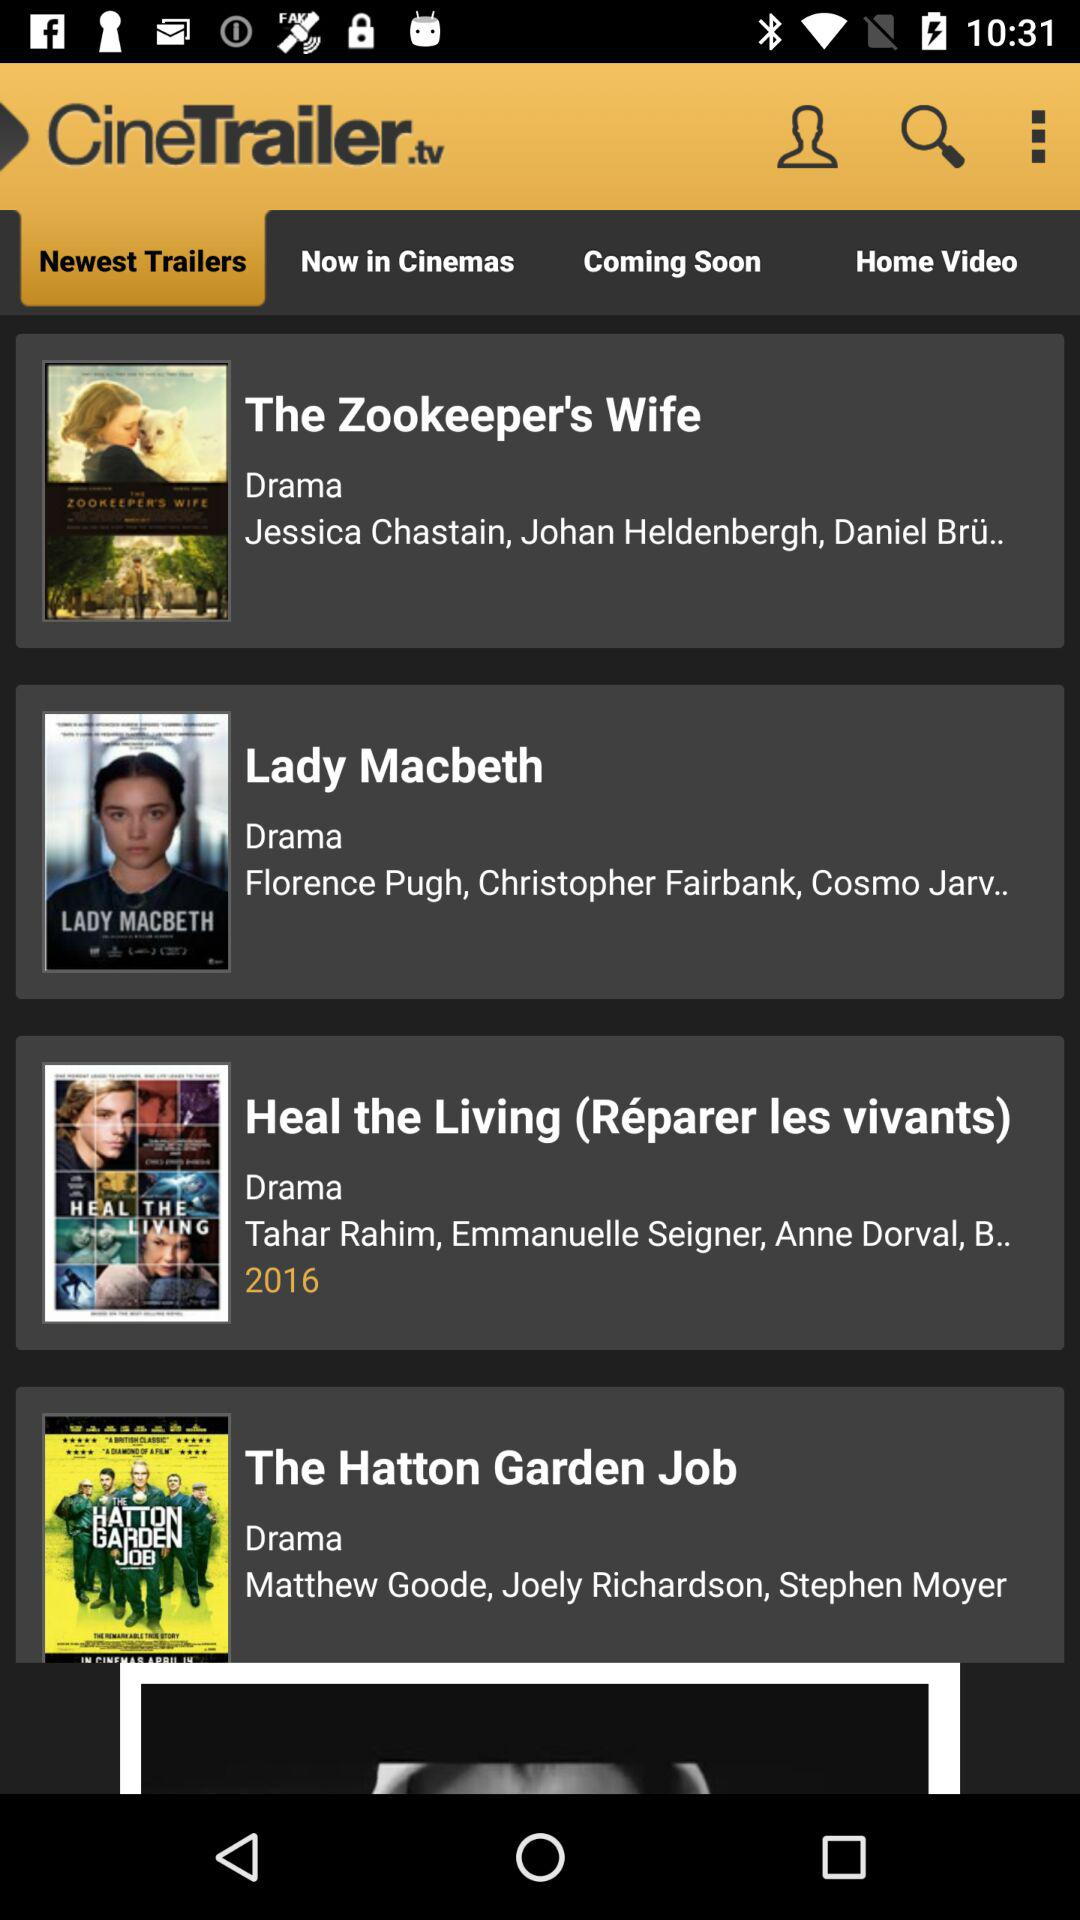What's the genre of "Lady Macbeth"? The genre of "Lady Macbeth" Drama. 